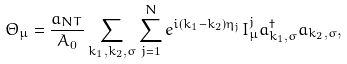Convert formula to latex. <formula><loc_0><loc_0><loc_500><loc_500>\Theta _ { \mu } = \frac { a _ { N T } } { A _ { 0 } } \sum _ { k _ { 1 } , k _ { 2 } , \sigma } \sum _ { j = 1 } ^ { N } e ^ { i ( k _ { 1 } - k _ { 2 } ) \eta _ { j } } I _ { \mu } ^ { j } a _ { k _ { 1 } , \sigma } ^ { \dag } a _ { k _ { 2 } , \sigma } ,</formula> 